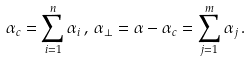<formula> <loc_0><loc_0><loc_500><loc_500>\alpha _ { c } = \sum _ { i = 1 } ^ { n } \alpha _ { i } \, , \, \alpha _ { \perp } = \alpha - \alpha _ { c } = \sum _ { j = 1 } ^ { m } \alpha _ { j } \, .</formula> 